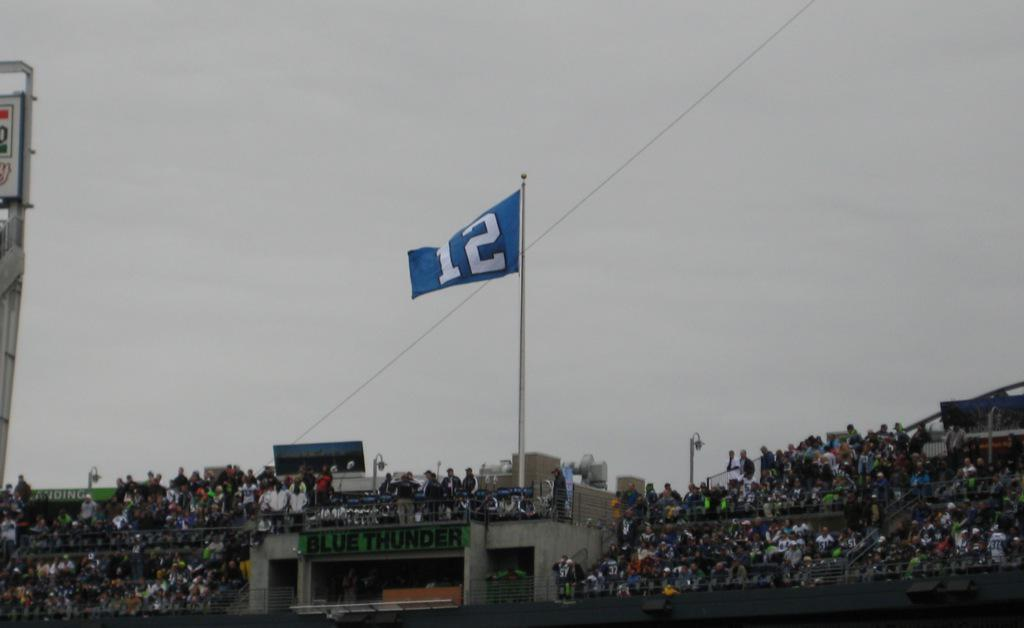Provide a one-sentence caption for the provided image. A blue flag rising above a stadium with a white number 12 on it. 